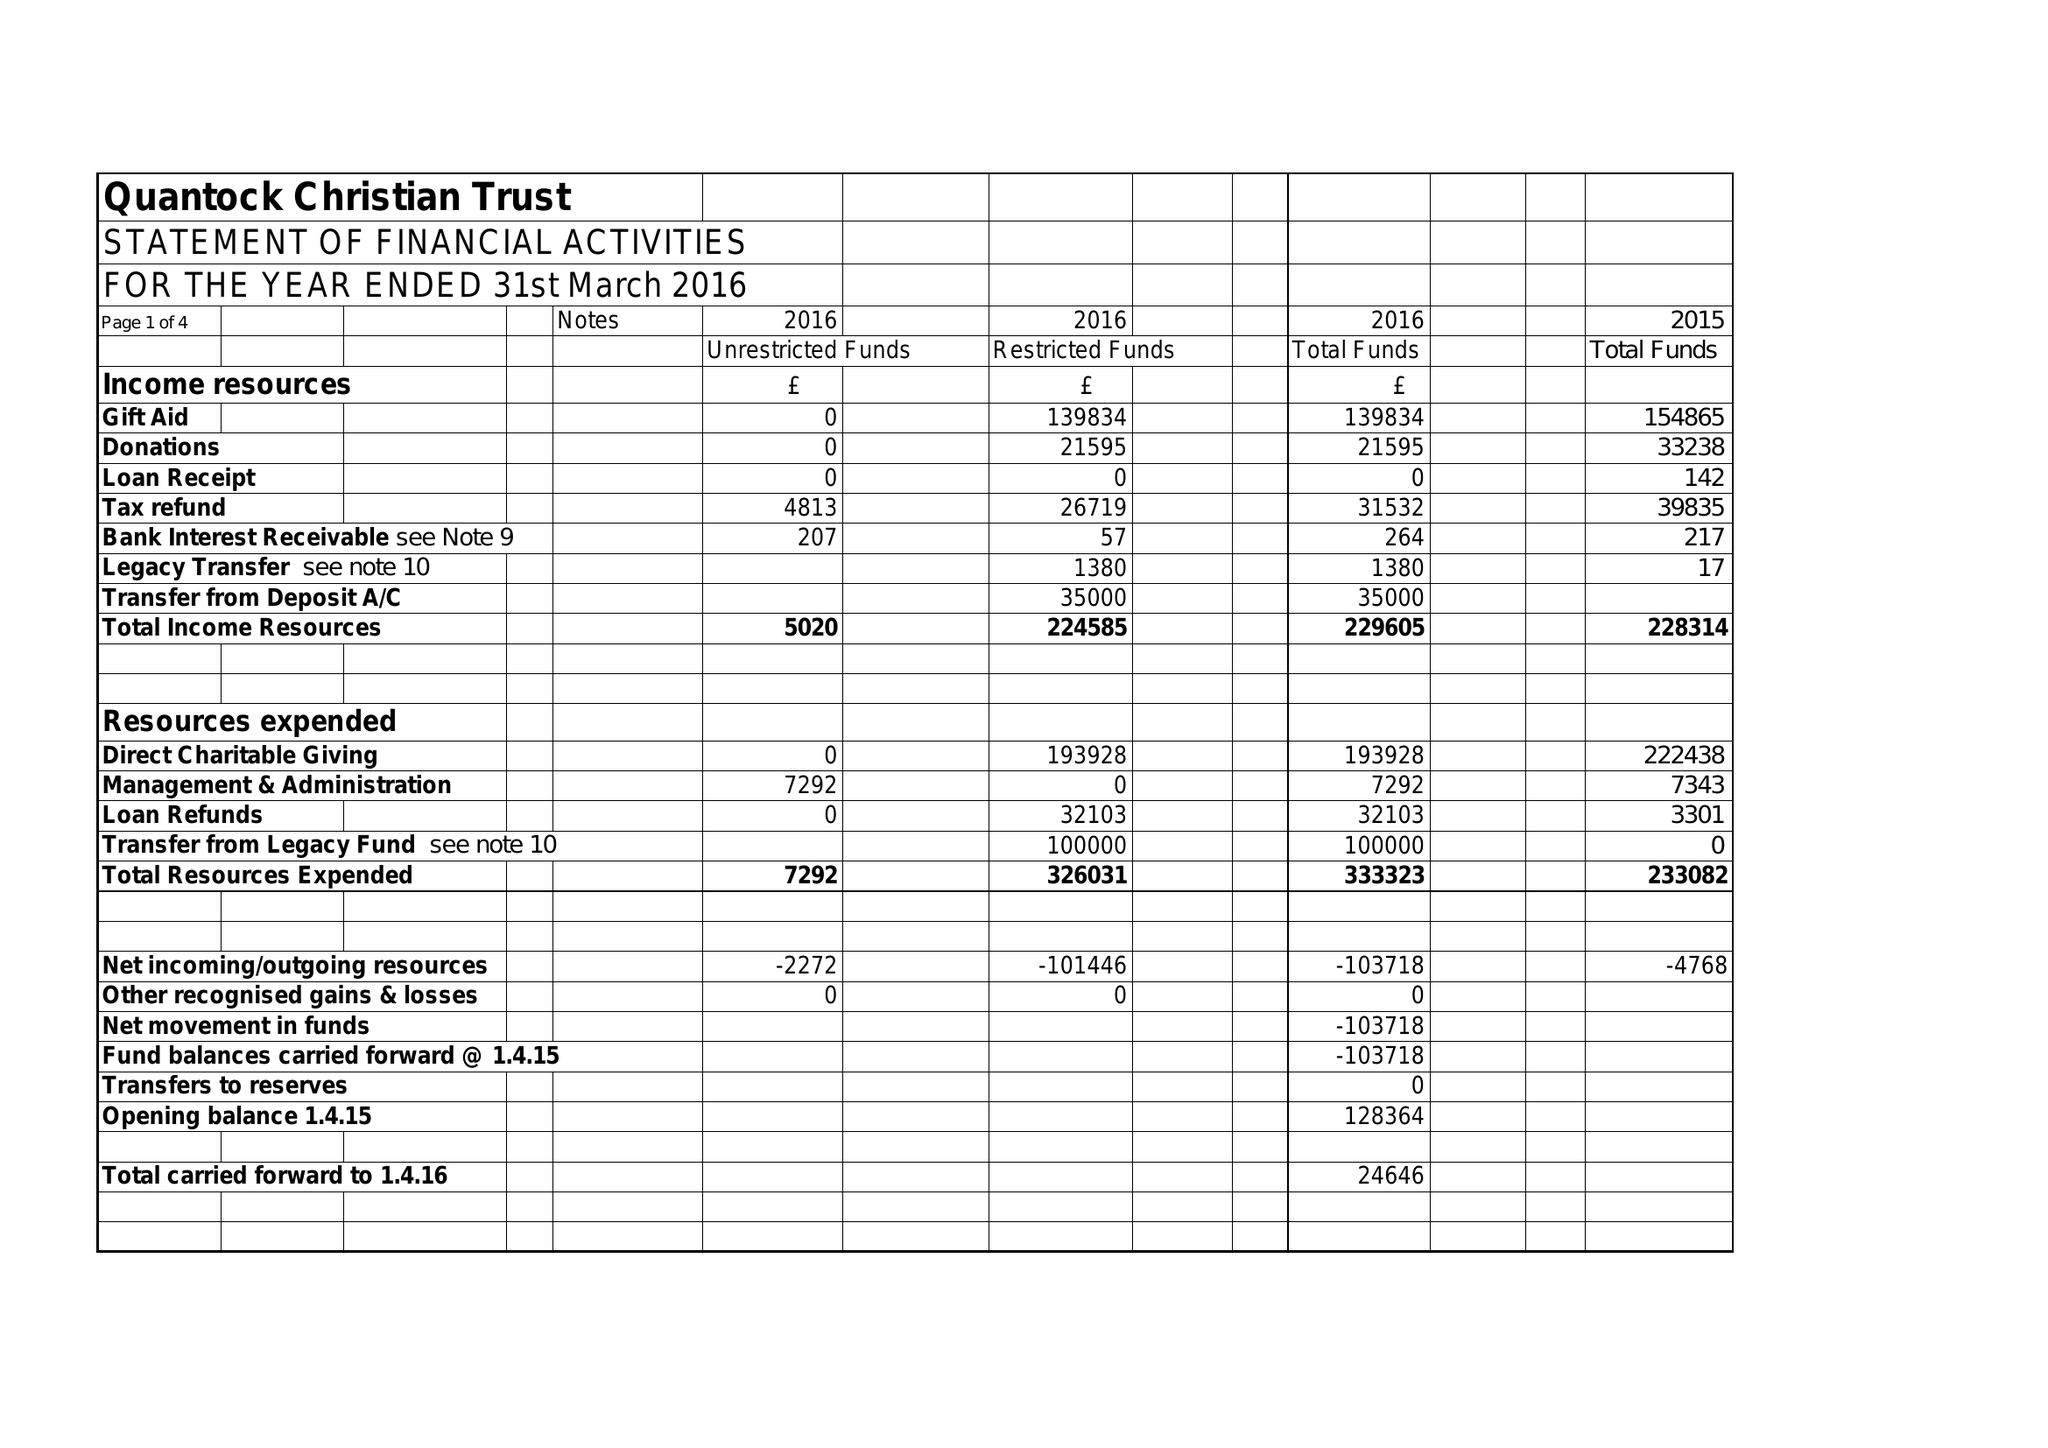What is the value for the spending_annually_in_british_pounds?
Answer the question using a single word or phrase. 233323.00 